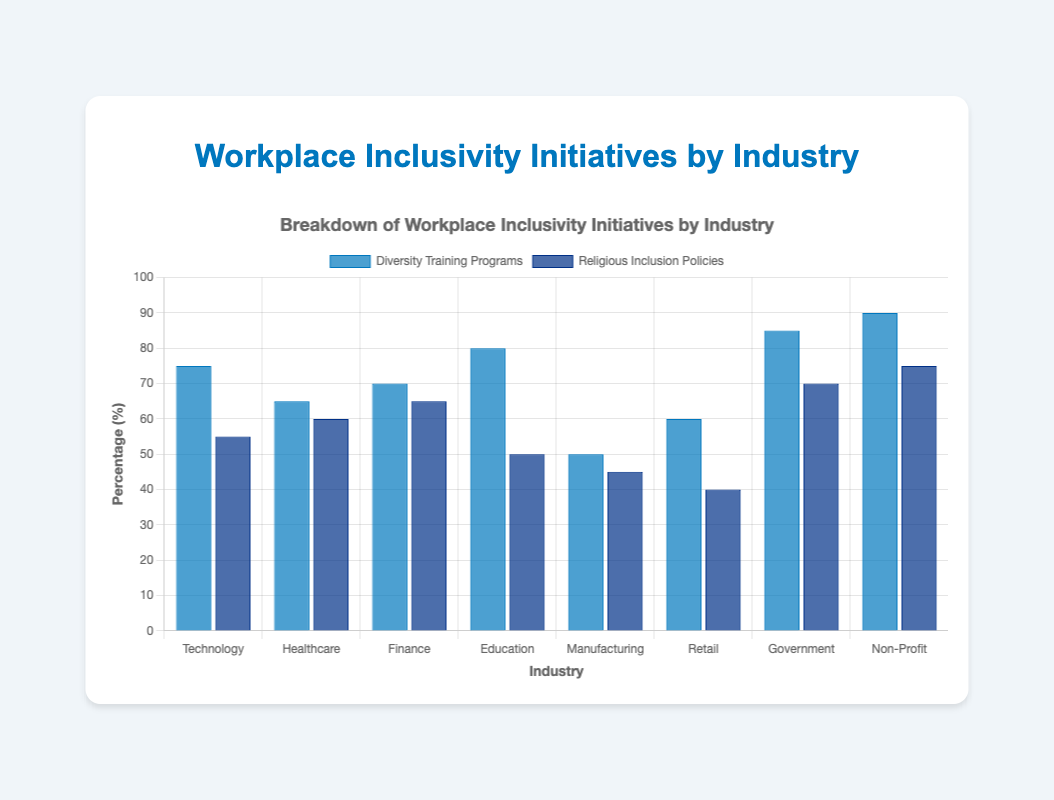What is the industry with the highest percentage of Diversity Training Programs? According to the figure, the Non-Profit industry has the highest bar for Diversity Training Programs at 90%.
Answer: Non-Profit Which industry has a higher percentage of Religious Inclusion Policies: Technology or Finance? In the figure, Technology has a bar at 55% for Religious Inclusion Policies and Finance has a bar at 65%. Therefore, Finance has a higher percentage.
Answer: Finance What is the difference in percentage points between Diversity Training Programs and Religious Inclusion Policies in the Government industry? For the Government industry, the Diversity Training Programs percentage is 85% and the Religious Inclusion Policies percentage is 70%. The difference is 85 - 70 = 15 percentage points.
Answer: 15 What is the average percentage of Diversity Training Programs across all industries? Sum the percentages for Diversity Training Programs (75+65+70+80+50+60+85+90 = 575) and divide by the number of industries (8). The average is 575 / 8 = 71.875%.
Answer: 71.875 Which industry shows a greater emphasis on Religious Inclusion Policies compared to Diversity Training Programs? The figure shows that in the Retail industry, the bar for Religious Inclusion Policies is higher (40%) compared to Diversity Training Programs (60%), signaling a lower emphasis on Religious Inclusion Policies. The other industries have Diversity Training Programs at a higher percentage than Religious Inclusion Policies. Therefore, no industry shows a greater emphasis on Religious Inclusion Policies.
Answer: None What is the combined percentage of Diversity Training Programs and Religious Inclusion Policies for the Healthcare industry? In the Healthcare industry, the percentage for Diversity Training Programs is 65%, and for Religious Inclusion Policies, it is 60%. The combined percentage is 65 + 60 = 125%.
Answer: 125% Are there any industries where the percentage of Religious Inclusion Policies is greater than 70%? According to the bars in the figure, both Government and Non-Profit industries have percentages for Religious Inclusion Policies greater than 70%, with Government at 70% and Non-Profit at 75%.
Answer: Yes What is the difference between Diversity Training Programs and Religious Inclusion Policies in the Manufacturing industry? For the Manufacturing industry, the percentage for Diversity Training Programs is 50% and for Religious Inclusion Policies, it is 45%. The difference is 50 - 45 = 5 percentage points.
Answer: 5 Which industry has the smallest percentage for Religious Inclusion Policies? The figure indicates that the Retail industry has the smallest bar for Religious Inclusion Policies at 40%.
Answer: Retail How much greater is the percentage of Diversity Training Programs compared to Religious Inclusion Policies in the Technology industry? In the Technology industry, Diversity Training Programs are at 75%, and Religious Inclusion Policies are at 55%. The difference is 75 - 55 = 20 percentage points.
Answer: 20 